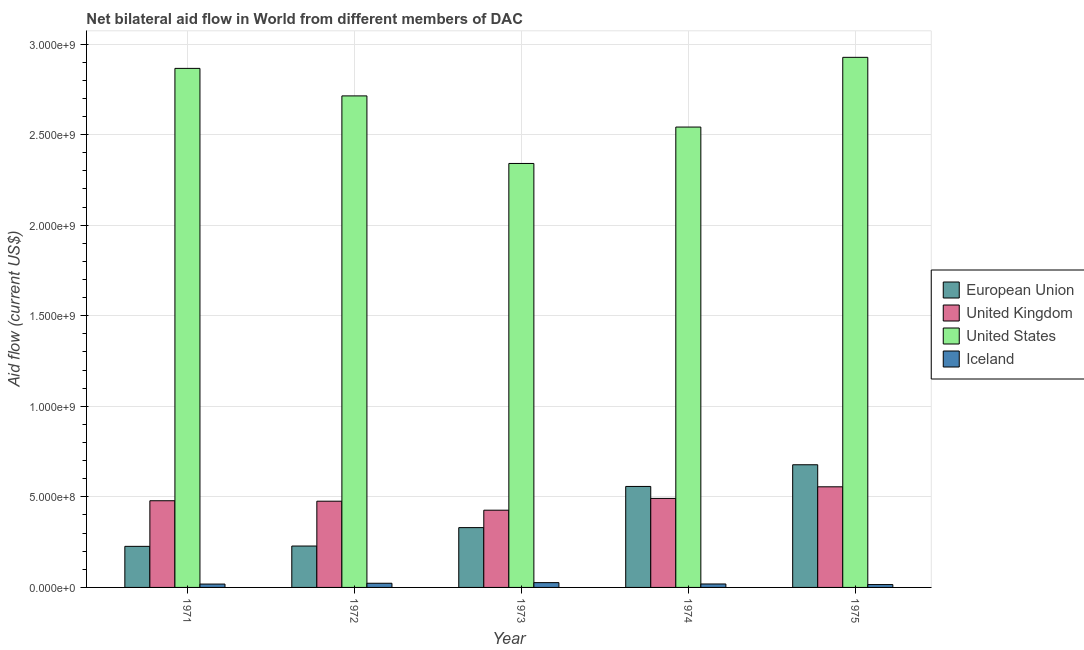How many groups of bars are there?
Offer a very short reply. 5. What is the label of the 5th group of bars from the left?
Offer a very short reply. 1975. In how many cases, is the number of bars for a given year not equal to the number of legend labels?
Keep it short and to the point. 0. What is the amount of aid given by uk in 1974?
Provide a short and direct response. 4.92e+08. Across all years, what is the maximum amount of aid given by iceland?
Offer a terse response. 2.65e+07. Across all years, what is the minimum amount of aid given by uk?
Provide a succinct answer. 4.26e+08. In which year was the amount of aid given by us maximum?
Keep it short and to the point. 1975. In which year was the amount of aid given by iceland minimum?
Ensure brevity in your answer.  1975. What is the total amount of aid given by eu in the graph?
Your answer should be very brief. 2.02e+09. What is the difference between the amount of aid given by eu in 1972 and that in 1975?
Give a very brief answer. -4.49e+08. What is the difference between the amount of aid given by uk in 1974 and the amount of aid given by eu in 1975?
Your response must be concise. -6.41e+07. What is the average amount of aid given by iceland per year?
Your answer should be compact. 2.06e+07. What is the ratio of the amount of aid given by us in 1972 to that in 1975?
Ensure brevity in your answer.  0.93. Is the amount of aid given by iceland in 1971 less than that in 1975?
Make the answer very short. No. What is the difference between the highest and the second highest amount of aid given by us?
Provide a succinct answer. 6.10e+07. What is the difference between the highest and the lowest amount of aid given by uk?
Give a very brief answer. 1.29e+08. Is the sum of the amount of aid given by uk in 1973 and 1974 greater than the maximum amount of aid given by iceland across all years?
Give a very brief answer. Yes. Is it the case that in every year, the sum of the amount of aid given by eu and amount of aid given by iceland is greater than the sum of amount of aid given by us and amount of aid given by uk?
Provide a short and direct response. No. What does the 3rd bar from the right in 1973 represents?
Your answer should be compact. United Kingdom. How many bars are there?
Ensure brevity in your answer.  20. What is the difference between two consecutive major ticks on the Y-axis?
Offer a terse response. 5.00e+08. How many legend labels are there?
Your answer should be very brief. 4. How are the legend labels stacked?
Your response must be concise. Vertical. What is the title of the graph?
Your response must be concise. Net bilateral aid flow in World from different members of DAC. What is the Aid flow (current US$) of European Union in 1971?
Provide a short and direct response. 2.27e+08. What is the Aid flow (current US$) of United Kingdom in 1971?
Provide a succinct answer. 4.79e+08. What is the Aid flow (current US$) in United States in 1971?
Your response must be concise. 2.87e+09. What is the Aid flow (current US$) in Iceland in 1971?
Offer a very short reply. 1.85e+07. What is the Aid flow (current US$) of European Union in 1972?
Your answer should be very brief. 2.29e+08. What is the Aid flow (current US$) in United Kingdom in 1972?
Keep it short and to the point. 4.76e+08. What is the Aid flow (current US$) in United States in 1972?
Give a very brief answer. 2.71e+09. What is the Aid flow (current US$) in Iceland in 1972?
Provide a succinct answer. 2.30e+07. What is the Aid flow (current US$) in European Union in 1973?
Offer a terse response. 3.30e+08. What is the Aid flow (current US$) of United Kingdom in 1973?
Provide a succinct answer. 4.26e+08. What is the Aid flow (current US$) in United States in 1973?
Ensure brevity in your answer.  2.34e+09. What is the Aid flow (current US$) in Iceland in 1973?
Keep it short and to the point. 2.65e+07. What is the Aid flow (current US$) of European Union in 1974?
Ensure brevity in your answer.  5.58e+08. What is the Aid flow (current US$) of United Kingdom in 1974?
Give a very brief answer. 4.92e+08. What is the Aid flow (current US$) in United States in 1974?
Provide a succinct answer. 2.54e+09. What is the Aid flow (current US$) of Iceland in 1974?
Give a very brief answer. 1.90e+07. What is the Aid flow (current US$) of European Union in 1975?
Give a very brief answer. 6.77e+08. What is the Aid flow (current US$) in United Kingdom in 1975?
Ensure brevity in your answer.  5.56e+08. What is the Aid flow (current US$) in United States in 1975?
Provide a succinct answer. 2.93e+09. What is the Aid flow (current US$) of Iceland in 1975?
Provide a short and direct response. 1.58e+07. Across all years, what is the maximum Aid flow (current US$) in European Union?
Provide a succinct answer. 6.77e+08. Across all years, what is the maximum Aid flow (current US$) in United Kingdom?
Make the answer very short. 5.56e+08. Across all years, what is the maximum Aid flow (current US$) in United States?
Your answer should be very brief. 2.93e+09. Across all years, what is the maximum Aid flow (current US$) in Iceland?
Ensure brevity in your answer.  2.65e+07. Across all years, what is the minimum Aid flow (current US$) in European Union?
Your response must be concise. 2.27e+08. Across all years, what is the minimum Aid flow (current US$) of United Kingdom?
Your answer should be compact. 4.26e+08. Across all years, what is the minimum Aid flow (current US$) in United States?
Offer a terse response. 2.34e+09. Across all years, what is the minimum Aid flow (current US$) in Iceland?
Keep it short and to the point. 1.58e+07. What is the total Aid flow (current US$) of European Union in the graph?
Ensure brevity in your answer.  2.02e+09. What is the total Aid flow (current US$) of United Kingdom in the graph?
Keep it short and to the point. 2.43e+09. What is the total Aid flow (current US$) in United States in the graph?
Provide a succinct answer. 1.34e+1. What is the total Aid flow (current US$) of Iceland in the graph?
Your answer should be very brief. 1.03e+08. What is the difference between the Aid flow (current US$) in European Union in 1971 and that in 1972?
Make the answer very short. -1.74e+06. What is the difference between the Aid flow (current US$) in United Kingdom in 1971 and that in 1972?
Your response must be concise. 2.50e+06. What is the difference between the Aid flow (current US$) of United States in 1971 and that in 1972?
Your response must be concise. 1.52e+08. What is the difference between the Aid flow (current US$) in Iceland in 1971 and that in 1972?
Your answer should be compact. -4.51e+06. What is the difference between the Aid flow (current US$) of European Union in 1971 and that in 1973?
Offer a terse response. -1.04e+08. What is the difference between the Aid flow (current US$) in United Kingdom in 1971 and that in 1973?
Your answer should be very brief. 5.22e+07. What is the difference between the Aid flow (current US$) in United States in 1971 and that in 1973?
Give a very brief answer. 5.25e+08. What is the difference between the Aid flow (current US$) in Iceland in 1971 and that in 1973?
Make the answer very short. -7.99e+06. What is the difference between the Aid flow (current US$) in European Union in 1971 and that in 1974?
Provide a short and direct response. -3.31e+08. What is the difference between the Aid flow (current US$) in United Kingdom in 1971 and that in 1974?
Offer a terse response. -1.29e+07. What is the difference between the Aid flow (current US$) of United States in 1971 and that in 1974?
Give a very brief answer. 3.24e+08. What is the difference between the Aid flow (current US$) of Iceland in 1971 and that in 1974?
Provide a succinct answer. -5.40e+05. What is the difference between the Aid flow (current US$) of European Union in 1971 and that in 1975?
Your response must be concise. -4.51e+08. What is the difference between the Aid flow (current US$) of United Kingdom in 1971 and that in 1975?
Make the answer very short. -7.70e+07. What is the difference between the Aid flow (current US$) in United States in 1971 and that in 1975?
Offer a terse response. -6.10e+07. What is the difference between the Aid flow (current US$) of Iceland in 1971 and that in 1975?
Provide a succinct answer. 2.70e+06. What is the difference between the Aid flow (current US$) of European Union in 1972 and that in 1973?
Keep it short and to the point. -1.02e+08. What is the difference between the Aid flow (current US$) in United Kingdom in 1972 and that in 1973?
Keep it short and to the point. 4.97e+07. What is the difference between the Aid flow (current US$) of United States in 1972 and that in 1973?
Your response must be concise. 3.73e+08. What is the difference between the Aid flow (current US$) in Iceland in 1972 and that in 1973?
Your answer should be very brief. -3.48e+06. What is the difference between the Aid flow (current US$) of European Union in 1972 and that in 1974?
Your response must be concise. -3.29e+08. What is the difference between the Aid flow (current US$) of United Kingdom in 1972 and that in 1974?
Offer a very short reply. -1.54e+07. What is the difference between the Aid flow (current US$) in United States in 1972 and that in 1974?
Offer a very short reply. 1.72e+08. What is the difference between the Aid flow (current US$) of Iceland in 1972 and that in 1974?
Give a very brief answer. 3.97e+06. What is the difference between the Aid flow (current US$) of European Union in 1972 and that in 1975?
Provide a succinct answer. -4.49e+08. What is the difference between the Aid flow (current US$) of United Kingdom in 1972 and that in 1975?
Make the answer very short. -7.95e+07. What is the difference between the Aid flow (current US$) in United States in 1972 and that in 1975?
Offer a very short reply. -2.13e+08. What is the difference between the Aid flow (current US$) of Iceland in 1972 and that in 1975?
Provide a short and direct response. 7.21e+06. What is the difference between the Aid flow (current US$) in European Union in 1973 and that in 1974?
Make the answer very short. -2.27e+08. What is the difference between the Aid flow (current US$) of United Kingdom in 1973 and that in 1974?
Your response must be concise. -6.50e+07. What is the difference between the Aid flow (current US$) in United States in 1973 and that in 1974?
Your response must be concise. -2.01e+08. What is the difference between the Aid flow (current US$) in Iceland in 1973 and that in 1974?
Give a very brief answer. 7.45e+06. What is the difference between the Aid flow (current US$) in European Union in 1973 and that in 1975?
Provide a short and direct response. -3.47e+08. What is the difference between the Aid flow (current US$) of United Kingdom in 1973 and that in 1975?
Offer a terse response. -1.29e+08. What is the difference between the Aid flow (current US$) of United States in 1973 and that in 1975?
Your answer should be compact. -5.86e+08. What is the difference between the Aid flow (current US$) of Iceland in 1973 and that in 1975?
Ensure brevity in your answer.  1.07e+07. What is the difference between the Aid flow (current US$) of European Union in 1974 and that in 1975?
Your answer should be compact. -1.20e+08. What is the difference between the Aid flow (current US$) in United Kingdom in 1974 and that in 1975?
Provide a succinct answer. -6.41e+07. What is the difference between the Aid flow (current US$) of United States in 1974 and that in 1975?
Your answer should be compact. -3.85e+08. What is the difference between the Aid flow (current US$) in Iceland in 1974 and that in 1975?
Offer a very short reply. 3.24e+06. What is the difference between the Aid flow (current US$) in European Union in 1971 and the Aid flow (current US$) in United Kingdom in 1972?
Your response must be concise. -2.49e+08. What is the difference between the Aid flow (current US$) in European Union in 1971 and the Aid flow (current US$) in United States in 1972?
Make the answer very short. -2.49e+09. What is the difference between the Aid flow (current US$) of European Union in 1971 and the Aid flow (current US$) of Iceland in 1972?
Your answer should be compact. 2.04e+08. What is the difference between the Aid flow (current US$) in United Kingdom in 1971 and the Aid flow (current US$) in United States in 1972?
Offer a very short reply. -2.24e+09. What is the difference between the Aid flow (current US$) of United Kingdom in 1971 and the Aid flow (current US$) of Iceland in 1972?
Provide a short and direct response. 4.56e+08. What is the difference between the Aid flow (current US$) in United States in 1971 and the Aid flow (current US$) in Iceland in 1972?
Your response must be concise. 2.84e+09. What is the difference between the Aid flow (current US$) of European Union in 1971 and the Aid flow (current US$) of United Kingdom in 1973?
Keep it short and to the point. -2.00e+08. What is the difference between the Aid flow (current US$) of European Union in 1971 and the Aid flow (current US$) of United States in 1973?
Offer a very short reply. -2.11e+09. What is the difference between the Aid flow (current US$) in European Union in 1971 and the Aid flow (current US$) in Iceland in 1973?
Your answer should be very brief. 2.00e+08. What is the difference between the Aid flow (current US$) of United Kingdom in 1971 and the Aid flow (current US$) of United States in 1973?
Your answer should be very brief. -1.86e+09. What is the difference between the Aid flow (current US$) in United Kingdom in 1971 and the Aid flow (current US$) in Iceland in 1973?
Your answer should be compact. 4.52e+08. What is the difference between the Aid flow (current US$) of United States in 1971 and the Aid flow (current US$) of Iceland in 1973?
Provide a short and direct response. 2.84e+09. What is the difference between the Aid flow (current US$) of European Union in 1971 and the Aid flow (current US$) of United Kingdom in 1974?
Offer a very short reply. -2.65e+08. What is the difference between the Aid flow (current US$) in European Union in 1971 and the Aid flow (current US$) in United States in 1974?
Give a very brief answer. -2.32e+09. What is the difference between the Aid flow (current US$) of European Union in 1971 and the Aid flow (current US$) of Iceland in 1974?
Your answer should be compact. 2.08e+08. What is the difference between the Aid flow (current US$) of United Kingdom in 1971 and the Aid flow (current US$) of United States in 1974?
Ensure brevity in your answer.  -2.06e+09. What is the difference between the Aid flow (current US$) of United Kingdom in 1971 and the Aid flow (current US$) of Iceland in 1974?
Make the answer very short. 4.60e+08. What is the difference between the Aid flow (current US$) in United States in 1971 and the Aid flow (current US$) in Iceland in 1974?
Your answer should be very brief. 2.85e+09. What is the difference between the Aid flow (current US$) of European Union in 1971 and the Aid flow (current US$) of United Kingdom in 1975?
Your answer should be compact. -3.29e+08. What is the difference between the Aid flow (current US$) in European Union in 1971 and the Aid flow (current US$) in United States in 1975?
Your answer should be very brief. -2.70e+09. What is the difference between the Aid flow (current US$) of European Union in 1971 and the Aid flow (current US$) of Iceland in 1975?
Provide a succinct answer. 2.11e+08. What is the difference between the Aid flow (current US$) of United Kingdom in 1971 and the Aid flow (current US$) of United States in 1975?
Ensure brevity in your answer.  -2.45e+09. What is the difference between the Aid flow (current US$) of United Kingdom in 1971 and the Aid flow (current US$) of Iceland in 1975?
Provide a short and direct response. 4.63e+08. What is the difference between the Aid flow (current US$) in United States in 1971 and the Aid flow (current US$) in Iceland in 1975?
Offer a terse response. 2.85e+09. What is the difference between the Aid flow (current US$) in European Union in 1972 and the Aid flow (current US$) in United Kingdom in 1973?
Give a very brief answer. -1.98e+08. What is the difference between the Aid flow (current US$) in European Union in 1972 and the Aid flow (current US$) in United States in 1973?
Your answer should be compact. -2.11e+09. What is the difference between the Aid flow (current US$) of European Union in 1972 and the Aid flow (current US$) of Iceland in 1973?
Your answer should be compact. 2.02e+08. What is the difference between the Aid flow (current US$) in United Kingdom in 1972 and the Aid flow (current US$) in United States in 1973?
Your answer should be compact. -1.86e+09. What is the difference between the Aid flow (current US$) of United Kingdom in 1972 and the Aid flow (current US$) of Iceland in 1973?
Provide a succinct answer. 4.50e+08. What is the difference between the Aid flow (current US$) in United States in 1972 and the Aid flow (current US$) in Iceland in 1973?
Offer a very short reply. 2.69e+09. What is the difference between the Aid flow (current US$) in European Union in 1972 and the Aid flow (current US$) in United Kingdom in 1974?
Ensure brevity in your answer.  -2.63e+08. What is the difference between the Aid flow (current US$) in European Union in 1972 and the Aid flow (current US$) in United States in 1974?
Provide a succinct answer. -2.31e+09. What is the difference between the Aid flow (current US$) of European Union in 1972 and the Aid flow (current US$) of Iceland in 1974?
Make the answer very short. 2.09e+08. What is the difference between the Aid flow (current US$) of United Kingdom in 1972 and the Aid flow (current US$) of United States in 1974?
Your answer should be very brief. -2.07e+09. What is the difference between the Aid flow (current US$) of United Kingdom in 1972 and the Aid flow (current US$) of Iceland in 1974?
Give a very brief answer. 4.57e+08. What is the difference between the Aid flow (current US$) in United States in 1972 and the Aid flow (current US$) in Iceland in 1974?
Make the answer very short. 2.69e+09. What is the difference between the Aid flow (current US$) in European Union in 1972 and the Aid flow (current US$) in United Kingdom in 1975?
Make the answer very short. -3.27e+08. What is the difference between the Aid flow (current US$) of European Union in 1972 and the Aid flow (current US$) of United States in 1975?
Provide a succinct answer. -2.70e+09. What is the difference between the Aid flow (current US$) of European Union in 1972 and the Aid flow (current US$) of Iceland in 1975?
Ensure brevity in your answer.  2.13e+08. What is the difference between the Aid flow (current US$) in United Kingdom in 1972 and the Aid flow (current US$) in United States in 1975?
Your answer should be very brief. -2.45e+09. What is the difference between the Aid flow (current US$) in United Kingdom in 1972 and the Aid flow (current US$) in Iceland in 1975?
Your response must be concise. 4.60e+08. What is the difference between the Aid flow (current US$) of United States in 1972 and the Aid flow (current US$) of Iceland in 1975?
Ensure brevity in your answer.  2.70e+09. What is the difference between the Aid flow (current US$) of European Union in 1973 and the Aid flow (current US$) of United Kingdom in 1974?
Your answer should be very brief. -1.61e+08. What is the difference between the Aid flow (current US$) of European Union in 1973 and the Aid flow (current US$) of United States in 1974?
Your answer should be very brief. -2.21e+09. What is the difference between the Aid flow (current US$) of European Union in 1973 and the Aid flow (current US$) of Iceland in 1974?
Your response must be concise. 3.11e+08. What is the difference between the Aid flow (current US$) in United Kingdom in 1973 and the Aid flow (current US$) in United States in 1974?
Offer a very short reply. -2.12e+09. What is the difference between the Aid flow (current US$) of United Kingdom in 1973 and the Aid flow (current US$) of Iceland in 1974?
Keep it short and to the point. 4.07e+08. What is the difference between the Aid flow (current US$) in United States in 1973 and the Aid flow (current US$) in Iceland in 1974?
Provide a short and direct response. 2.32e+09. What is the difference between the Aid flow (current US$) in European Union in 1973 and the Aid flow (current US$) in United Kingdom in 1975?
Offer a terse response. -2.25e+08. What is the difference between the Aid flow (current US$) in European Union in 1973 and the Aid flow (current US$) in United States in 1975?
Make the answer very short. -2.60e+09. What is the difference between the Aid flow (current US$) in European Union in 1973 and the Aid flow (current US$) in Iceland in 1975?
Make the answer very short. 3.14e+08. What is the difference between the Aid flow (current US$) of United Kingdom in 1973 and the Aid flow (current US$) of United States in 1975?
Offer a terse response. -2.50e+09. What is the difference between the Aid flow (current US$) in United Kingdom in 1973 and the Aid flow (current US$) in Iceland in 1975?
Your answer should be very brief. 4.11e+08. What is the difference between the Aid flow (current US$) of United States in 1973 and the Aid flow (current US$) of Iceland in 1975?
Offer a very short reply. 2.33e+09. What is the difference between the Aid flow (current US$) in European Union in 1974 and the Aid flow (current US$) in United Kingdom in 1975?
Your answer should be compact. 1.97e+06. What is the difference between the Aid flow (current US$) in European Union in 1974 and the Aid flow (current US$) in United States in 1975?
Provide a succinct answer. -2.37e+09. What is the difference between the Aid flow (current US$) in European Union in 1974 and the Aid flow (current US$) in Iceland in 1975?
Offer a terse response. 5.42e+08. What is the difference between the Aid flow (current US$) in United Kingdom in 1974 and the Aid flow (current US$) in United States in 1975?
Provide a short and direct response. -2.44e+09. What is the difference between the Aid flow (current US$) of United Kingdom in 1974 and the Aid flow (current US$) of Iceland in 1975?
Give a very brief answer. 4.76e+08. What is the difference between the Aid flow (current US$) of United States in 1974 and the Aid flow (current US$) of Iceland in 1975?
Give a very brief answer. 2.53e+09. What is the average Aid flow (current US$) in European Union per year?
Offer a terse response. 4.04e+08. What is the average Aid flow (current US$) of United Kingdom per year?
Make the answer very short. 4.86e+08. What is the average Aid flow (current US$) of United States per year?
Your answer should be compact. 2.68e+09. What is the average Aid flow (current US$) of Iceland per year?
Provide a succinct answer. 2.06e+07. In the year 1971, what is the difference between the Aid flow (current US$) of European Union and Aid flow (current US$) of United Kingdom?
Your response must be concise. -2.52e+08. In the year 1971, what is the difference between the Aid flow (current US$) in European Union and Aid flow (current US$) in United States?
Provide a short and direct response. -2.64e+09. In the year 1971, what is the difference between the Aid flow (current US$) of European Union and Aid flow (current US$) of Iceland?
Your answer should be compact. 2.08e+08. In the year 1971, what is the difference between the Aid flow (current US$) in United Kingdom and Aid flow (current US$) in United States?
Make the answer very short. -2.39e+09. In the year 1971, what is the difference between the Aid flow (current US$) of United Kingdom and Aid flow (current US$) of Iceland?
Give a very brief answer. 4.60e+08. In the year 1971, what is the difference between the Aid flow (current US$) of United States and Aid flow (current US$) of Iceland?
Your answer should be compact. 2.85e+09. In the year 1972, what is the difference between the Aid flow (current US$) of European Union and Aid flow (current US$) of United Kingdom?
Keep it short and to the point. -2.48e+08. In the year 1972, what is the difference between the Aid flow (current US$) in European Union and Aid flow (current US$) in United States?
Offer a terse response. -2.49e+09. In the year 1972, what is the difference between the Aid flow (current US$) in European Union and Aid flow (current US$) in Iceland?
Give a very brief answer. 2.06e+08. In the year 1972, what is the difference between the Aid flow (current US$) in United Kingdom and Aid flow (current US$) in United States?
Provide a short and direct response. -2.24e+09. In the year 1972, what is the difference between the Aid flow (current US$) in United Kingdom and Aid flow (current US$) in Iceland?
Your answer should be compact. 4.53e+08. In the year 1972, what is the difference between the Aid flow (current US$) of United States and Aid flow (current US$) of Iceland?
Ensure brevity in your answer.  2.69e+09. In the year 1973, what is the difference between the Aid flow (current US$) in European Union and Aid flow (current US$) in United Kingdom?
Your answer should be compact. -9.62e+07. In the year 1973, what is the difference between the Aid flow (current US$) in European Union and Aid flow (current US$) in United States?
Ensure brevity in your answer.  -2.01e+09. In the year 1973, what is the difference between the Aid flow (current US$) in European Union and Aid flow (current US$) in Iceland?
Your answer should be very brief. 3.04e+08. In the year 1973, what is the difference between the Aid flow (current US$) in United Kingdom and Aid flow (current US$) in United States?
Provide a succinct answer. -1.91e+09. In the year 1973, what is the difference between the Aid flow (current US$) in United Kingdom and Aid flow (current US$) in Iceland?
Offer a terse response. 4.00e+08. In the year 1973, what is the difference between the Aid flow (current US$) in United States and Aid flow (current US$) in Iceland?
Provide a short and direct response. 2.31e+09. In the year 1974, what is the difference between the Aid flow (current US$) of European Union and Aid flow (current US$) of United Kingdom?
Your response must be concise. 6.61e+07. In the year 1974, what is the difference between the Aid flow (current US$) of European Union and Aid flow (current US$) of United States?
Offer a very short reply. -1.98e+09. In the year 1974, what is the difference between the Aid flow (current US$) of European Union and Aid flow (current US$) of Iceland?
Your answer should be very brief. 5.39e+08. In the year 1974, what is the difference between the Aid flow (current US$) of United Kingdom and Aid flow (current US$) of United States?
Give a very brief answer. -2.05e+09. In the year 1974, what is the difference between the Aid flow (current US$) in United Kingdom and Aid flow (current US$) in Iceland?
Offer a terse response. 4.72e+08. In the year 1974, what is the difference between the Aid flow (current US$) of United States and Aid flow (current US$) of Iceland?
Your answer should be compact. 2.52e+09. In the year 1975, what is the difference between the Aid flow (current US$) of European Union and Aid flow (current US$) of United Kingdom?
Provide a succinct answer. 1.22e+08. In the year 1975, what is the difference between the Aid flow (current US$) of European Union and Aid flow (current US$) of United States?
Keep it short and to the point. -2.25e+09. In the year 1975, what is the difference between the Aid flow (current US$) of European Union and Aid flow (current US$) of Iceland?
Provide a short and direct response. 6.62e+08. In the year 1975, what is the difference between the Aid flow (current US$) of United Kingdom and Aid flow (current US$) of United States?
Make the answer very short. -2.37e+09. In the year 1975, what is the difference between the Aid flow (current US$) of United Kingdom and Aid flow (current US$) of Iceland?
Keep it short and to the point. 5.40e+08. In the year 1975, what is the difference between the Aid flow (current US$) of United States and Aid flow (current US$) of Iceland?
Ensure brevity in your answer.  2.91e+09. What is the ratio of the Aid flow (current US$) of United Kingdom in 1971 to that in 1972?
Make the answer very short. 1.01. What is the ratio of the Aid flow (current US$) of United States in 1971 to that in 1972?
Ensure brevity in your answer.  1.06. What is the ratio of the Aid flow (current US$) of Iceland in 1971 to that in 1972?
Provide a succinct answer. 0.8. What is the ratio of the Aid flow (current US$) in European Union in 1971 to that in 1973?
Your answer should be compact. 0.69. What is the ratio of the Aid flow (current US$) in United Kingdom in 1971 to that in 1973?
Offer a very short reply. 1.12. What is the ratio of the Aid flow (current US$) of United States in 1971 to that in 1973?
Give a very brief answer. 1.22. What is the ratio of the Aid flow (current US$) in Iceland in 1971 to that in 1973?
Your answer should be very brief. 0.7. What is the ratio of the Aid flow (current US$) of European Union in 1971 to that in 1974?
Offer a terse response. 0.41. What is the ratio of the Aid flow (current US$) of United Kingdom in 1971 to that in 1974?
Ensure brevity in your answer.  0.97. What is the ratio of the Aid flow (current US$) in United States in 1971 to that in 1974?
Your answer should be very brief. 1.13. What is the ratio of the Aid flow (current US$) in Iceland in 1971 to that in 1974?
Offer a terse response. 0.97. What is the ratio of the Aid flow (current US$) in European Union in 1971 to that in 1975?
Ensure brevity in your answer.  0.33. What is the ratio of the Aid flow (current US$) of United Kingdom in 1971 to that in 1975?
Provide a short and direct response. 0.86. What is the ratio of the Aid flow (current US$) of United States in 1971 to that in 1975?
Provide a short and direct response. 0.98. What is the ratio of the Aid flow (current US$) of Iceland in 1971 to that in 1975?
Provide a succinct answer. 1.17. What is the ratio of the Aid flow (current US$) in European Union in 1972 to that in 1973?
Make the answer very short. 0.69. What is the ratio of the Aid flow (current US$) of United Kingdom in 1972 to that in 1973?
Your answer should be compact. 1.12. What is the ratio of the Aid flow (current US$) of United States in 1972 to that in 1973?
Make the answer very short. 1.16. What is the ratio of the Aid flow (current US$) of Iceland in 1972 to that in 1973?
Offer a terse response. 0.87. What is the ratio of the Aid flow (current US$) in European Union in 1972 to that in 1974?
Your response must be concise. 0.41. What is the ratio of the Aid flow (current US$) in United Kingdom in 1972 to that in 1974?
Your answer should be very brief. 0.97. What is the ratio of the Aid flow (current US$) in United States in 1972 to that in 1974?
Give a very brief answer. 1.07. What is the ratio of the Aid flow (current US$) of Iceland in 1972 to that in 1974?
Provide a succinct answer. 1.21. What is the ratio of the Aid flow (current US$) of European Union in 1972 to that in 1975?
Give a very brief answer. 0.34. What is the ratio of the Aid flow (current US$) in United Kingdom in 1972 to that in 1975?
Ensure brevity in your answer.  0.86. What is the ratio of the Aid flow (current US$) of United States in 1972 to that in 1975?
Provide a succinct answer. 0.93. What is the ratio of the Aid flow (current US$) in Iceland in 1972 to that in 1975?
Your answer should be compact. 1.46. What is the ratio of the Aid flow (current US$) in European Union in 1973 to that in 1974?
Your answer should be compact. 0.59. What is the ratio of the Aid flow (current US$) in United Kingdom in 1973 to that in 1974?
Give a very brief answer. 0.87. What is the ratio of the Aid flow (current US$) in United States in 1973 to that in 1974?
Provide a short and direct response. 0.92. What is the ratio of the Aid flow (current US$) of Iceland in 1973 to that in 1974?
Your response must be concise. 1.39. What is the ratio of the Aid flow (current US$) of European Union in 1973 to that in 1975?
Your answer should be very brief. 0.49. What is the ratio of the Aid flow (current US$) of United Kingdom in 1973 to that in 1975?
Your answer should be compact. 0.77. What is the ratio of the Aid flow (current US$) of United States in 1973 to that in 1975?
Keep it short and to the point. 0.8. What is the ratio of the Aid flow (current US$) in Iceland in 1973 to that in 1975?
Give a very brief answer. 1.68. What is the ratio of the Aid flow (current US$) of European Union in 1974 to that in 1975?
Keep it short and to the point. 0.82. What is the ratio of the Aid flow (current US$) in United Kingdom in 1974 to that in 1975?
Your answer should be very brief. 0.88. What is the ratio of the Aid flow (current US$) of United States in 1974 to that in 1975?
Provide a short and direct response. 0.87. What is the ratio of the Aid flow (current US$) of Iceland in 1974 to that in 1975?
Provide a succinct answer. 1.21. What is the difference between the highest and the second highest Aid flow (current US$) in European Union?
Provide a short and direct response. 1.20e+08. What is the difference between the highest and the second highest Aid flow (current US$) of United Kingdom?
Offer a terse response. 6.41e+07. What is the difference between the highest and the second highest Aid flow (current US$) of United States?
Offer a very short reply. 6.10e+07. What is the difference between the highest and the second highest Aid flow (current US$) in Iceland?
Your answer should be very brief. 3.48e+06. What is the difference between the highest and the lowest Aid flow (current US$) of European Union?
Provide a short and direct response. 4.51e+08. What is the difference between the highest and the lowest Aid flow (current US$) in United Kingdom?
Make the answer very short. 1.29e+08. What is the difference between the highest and the lowest Aid flow (current US$) in United States?
Provide a succinct answer. 5.86e+08. What is the difference between the highest and the lowest Aid flow (current US$) in Iceland?
Offer a very short reply. 1.07e+07. 